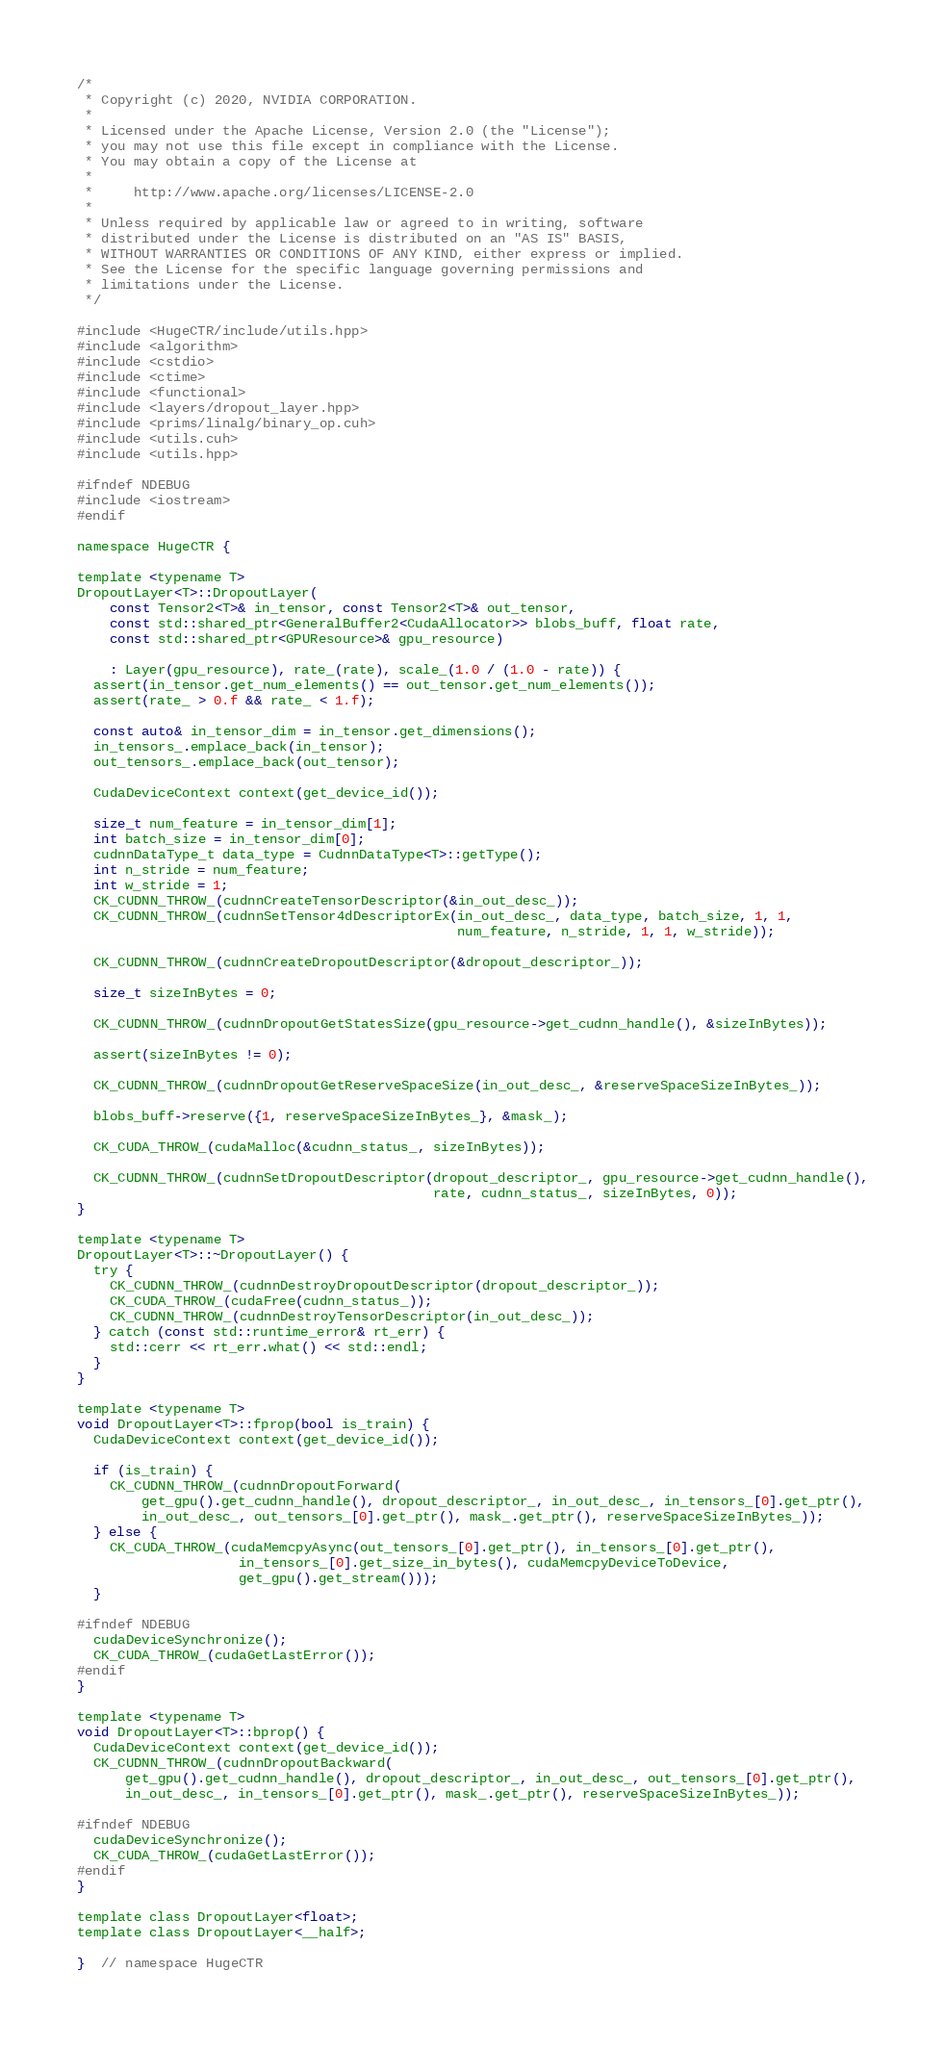<code> <loc_0><loc_0><loc_500><loc_500><_Cuda_>/*
 * Copyright (c) 2020, NVIDIA CORPORATION.
 *
 * Licensed under the Apache License, Version 2.0 (the "License");
 * you may not use this file except in compliance with the License.
 * You may obtain a copy of the License at
 *
 *     http://www.apache.org/licenses/LICENSE-2.0
 *
 * Unless required by applicable law or agreed to in writing, software
 * distributed under the License is distributed on an "AS IS" BASIS,
 * WITHOUT WARRANTIES OR CONDITIONS OF ANY KIND, either express or implied.
 * See the License for the specific language governing permissions and
 * limitations under the License.
 */

#include <HugeCTR/include/utils.hpp>
#include <algorithm>
#include <cstdio>
#include <ctime>
#include <functional>
#include <layers/dropout_layer.hpp>
#include <prims/linalg/binary_op.cuh>
#include <utils.cuh>
#include <utils.hpp>

#ifndef NDEBUG
#include <iostream>
#endif

namespace HugeCTR {

template <typename T>
DropoutLayer<T>::DropoutLayer(
    const Tensor2<T>& in_tensor, const Tensor2<T>& out_tensor,
    const std::shared_ptr<GeneralBuffer2<CudaAllocator>> blobs_buff, float rate,
    const std::shared_ptr<GPUResource>& gpu_resource)

    : Layer(gpu_resource), rate_(rate), scale_(1.0 / (1.0 - rate)) {
  assert(in_tensor.get_num_elements() == out_tensor.get_num_elements());
  assert(rate_ > 0.f && rate_ < 1.f);

  const auto& in_tensor_dim = in_tensor.get_dimensions();
  in_tensors_.emplace_back(in_tensor);
  out_tensors_.emplace_back(out_tensor);

  CudaDeviceContext context(get_device_id());

  size_t num_feature = in_tensor_dim[1];
  int batch_size = in_tensor_dim[0];
  cudnnDataType_t data_type = CudnnDataType<T>::getType();
  int n_stride = num_feature;
  int w_stride = 1;
  CK_CUDNN_THROW_(cudnnCreateTensorDescriptor(&in_out_desc_));
  CK_CUDNN_THROW_(cudnnSetTensor4dDescriptorEx(in_out_desc_, data_type, batch_size, 1, 1,
                                               num_feature, n_stride, 1, 1, w_stride));

  CK_CUDNN_THROW_(cudnnCreateDropoutDescriptor(&dropout_descriptor_));

  size_t sizeInBytes = 0;

  CK_CUDNN_THROW_(cudnnDropoutGetStatesSize(gpu_resource->get_cudnn_handle(), &sizeInBytes));

  assert(sizeInBytes != 0);

  CK_CUDNN_THROW_(cudnnDropoutGetReserveSpaceSize(in_out_desc_, &reserveSpaceSizeInBytes_));

  blobs_buff->reserve({1, reserveSpaceSizeInBytes_}, &mask_);

  CK_CUDA_THROW_(cudaMalloc(&cudnn_status_, sizeInBytes));

  CK_CUDNN_THROW_(cudnnSetDropoutDescriptor(dropout_descriptor_, gpu_resource->get_cudnn_handle(),
                                            rate, cudnn_status_, sizeInBytes, 0));
}

template <typename T>
DropoutLayer<T>::~DropoutLayer() {
  try {
    CK_CUDNN_THROW_(cudnnDestroyDropoutDescriptor(dropout_descriptor_));
    CK_CUDA_THROW_(cudaFree(cudnn_status_));
    CK_CUDNN_THROW_(cudnnDestroyTensorDescriptor(in_out_desc_));
  } catch (const std::runtime_error& rt_err) {
    std::cerr << rt_err.what() << std::endl;
  }
}

template <typename T>
void DropoutLayer<T>::fprop(bool is_train) {
  CudaDeviceContext context(get_device_id());

  if (is_train) {
    CK_CUDNN_THROW_(cudnnDropoutForward(
        get_gpu().get_cudnn_handle(), dropout_descriptor_, in_out_desc_, in_tensors_[0].get_ptr(),
        in_out_desc_, out_tensors_[0].get_ptr(), mask_.get_ptr(), reserveSpaceSizeInBytes_));
  } else {
    CK_CUDA_THROW_(cudaMemcpyAsync(out_tensors_[0].get_ptr(), in_tensors_[0].get_ptr(),
                    in_tensors_[0].get_size_in_bytes(), cudaMemcpyDeviceToDevice,
                    get_gpu().get_stream()));
  }

#ifndef NDEBUG
  cudaDeviceSynchronize();
  CK_CUDA_THROW_(cudaGetLastError());
#endif
}

template <typename T>
void DropoutLayer<T>::bprop() {
  CudaDeviceContext context(get_device_id());
  CK_CUDNN_THROW_(cudnnDropoutBackward(
      get_gpu().get_cudnn_handle(), dropout_descriptor_, in_out_desc_, out_tensors_[0].get_ptr(),
      in_out_desc_, in_tensors_[0].get_ptr(), mask_.get_ptr(), reserveSpaceSizeInBytes_));

#ifndef NDEBUG
  cudaDeviceSynchronize();
  CK_CUDA_THROW_(cudaGetLastError());
#endif
}

template class DropoutLayer<float>;
template class DropoutLayer<__half>;

}  // namespace HugeCTR
</code> 